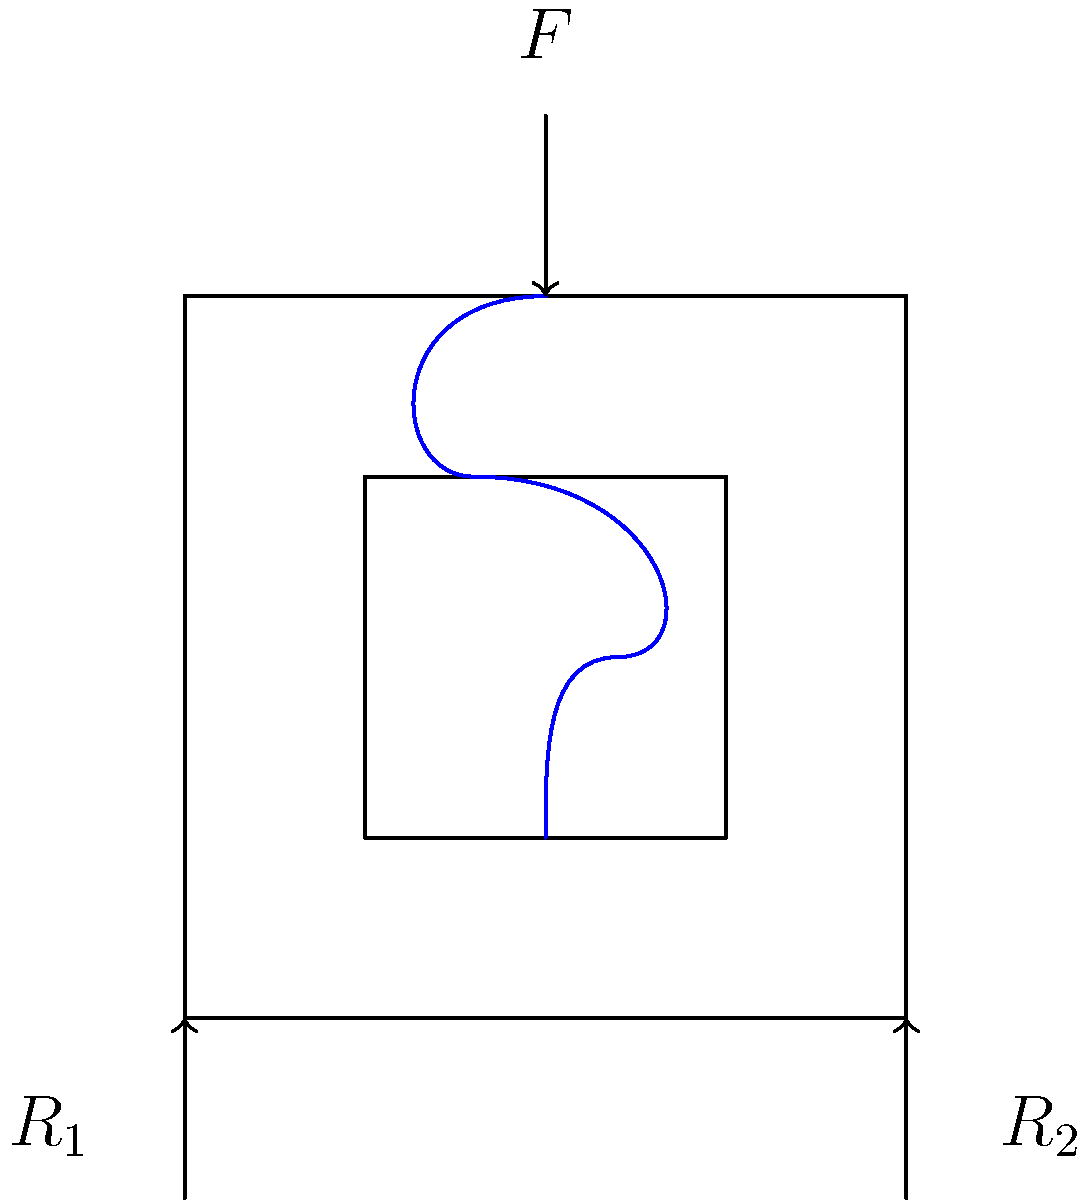In a vintage mechanical keyboard switch, a key press applies a force $F$ to compress the spring. If the switch housing experiences reaction forces $R_1$ and $R_2$ at its base, what is the relationship between these forces when the switch is in equilibrium? To solve this problem, we need to apply the principles of static equilibrium:

1. The sum of all forces must equal zero.
2. The sum of all moments about any point must equal zero.

Let's analyze the forces:

1. Vertical forces:
   The applied force $F$ is downward, while the reaction forces $R_1$ and $R_2$ are upward.

2. Equilibrium equation for vertical forces:
   $$F = R_1 + R_2$$

3. Moment equilibrium:
   Let's take moments about the left support (where $R_1$ acts). The distance between the supports is the width of the switch, which we'll call $w$.

   $$F \cdot \frac{w}{2} = R_2 \cdot w$$

4. Solving for $R_2$:
   $$R_2 = F \cdot \frac{1}{2}$$

5. Substituting this into the force equilibrium equation:
   $$F = R_1 + \frac{F}{2}$$

6. Solving for $R_1$:
   $$R_1 = F - \frac{F}{2} = \frac{F}{2}$$

Therefore, we can conclude that in equilibrium:
$$R_1 = R_2 = \frac{F}{2}$$

This means that the reaction forces are equal and each is half of the applied force.
Answer: $R_1 = R_2 = \frac{F}{2}$ 